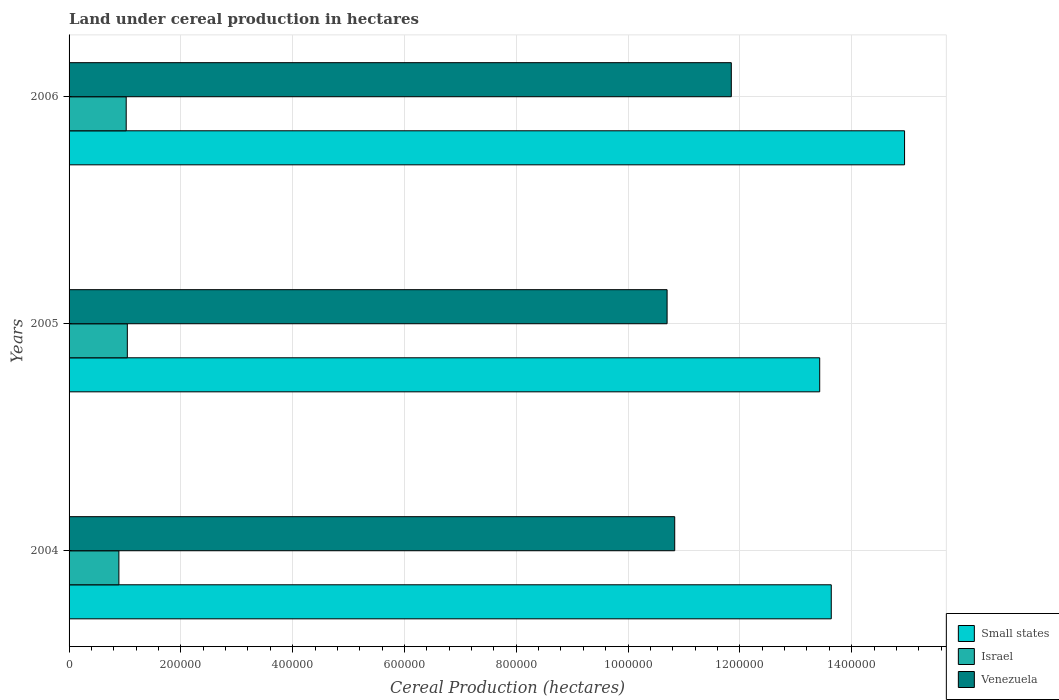How many different coloured bars are there?
Offer a terse response. 3. How many groups of bars are there?
Your response must be concise. 3. How many bars are there on the 3rd tick from the top?
Your answer should be compact. 3. How many bars are there on the 2nd tick from the bottom?
Your response must be concise. 3. What is the label of the 1st group of bars from the top?
Provide a succinct answer. 2006. What is the land under cereal production in Venezuela in 2005?
Ensure brevity in your answer.  1.07e+06. Across all years, what is the maximum land under cereal production in Small states?
Offer a terse response. 1.49e+06. Across all years, what is the minimum land under cereal production in Israel?
Ensure brevity in your answer.  8.91e+04. In which year was the land under cereal production in Israel minimum?
Your response must be concise. 2004. What is the total land under cereal production in Venezuela in the graph?
Keep it short and to the point. 3.34e+06. What is the difference between the land under cereal production in Small states in 2005 and that in 2006?
Keep it short and to the point. -1.52e+05. What is the difference between the land under cereal production in Venezuela in 2004 and the land under cereal production in Small states in 2005?
Provide a succinct answer. -2.59e+05. What is the average land under cereal production in Small states per year?
Give a very brief answer. 1.40e+06. In the year 2005, what is the difference between the land under cereal production in Small states and land under cereal production in Israel?
Offer a very short reply. 1.24e+06. In how many years, is the land under cereal production in Venezuela greater than 1280000 hectares?
Provide a short and direct response. 0. What is the ratio of the land under cereal production in Venezuela in 2004 to that in 2006?
Your response must be concise. 0.91. Is the land under cereal production in Israel in 2004 less than that in 2005?
Provide a short and direct response. Yes. What is the difference between the highest and the second highest land under cereal production in Small states?
Keep it short and to the point. 1.31e+05. What is the difference between the highest and the lowest land under cereal production in Small states?
Your answer should be very brief. 1.52e+05. What does the 3rd bar from the top in 2004 represents?
Keep it short and to the point. Small states. Is it the case that in every year, the sum of the land under cereal production in Israel and land under cereal production in Small states is greater than the land under cereal production in Venezuela?
Ensure brevity in your answer.  Yes. How many bars are there?
Offer a terse response. 9. Does the graph contain any zero values?
Your answer should be very brief. No. Does the graph contain grids?
Your answer should be very brief. Yes. How are the legend labels stacked?
Your answer should be compact. Vertical. What is the title of the graph?
Keep it short and to the point. Land under cereal production in hectares. What is the label or title of the X-axis?
Your answer should be compact. Cereal Production (hectares). What is the label or title of the Y-axis?
Offer a very short reply. Years. What is the Cereal Production (hectares) of Small states in 2004?
Offer a very short reply. 1.36e+06. What is the Cereal Production (hectares) in Israel in 2004?
Offer a very short reply. 8.91e+04. What is the Cereal Production (hectares) of Venezuela in 2004?
Your answer should be compact. 1.08e+06. What is the Cereal Production (hectares) of Small states in 2005?
Your answer should be very brief. 1.34e+06. What is the Cereal Production (hectares) of Israel in 2005?
Ensure brevity in your answer.  1.04e+05. What is the Cereal Production (hectares) in Venezuela in 2005?
Ensure brevity in your answer.  1.07e+06. What is the Cereal Production (hectares) of Small states in 2006?
Ensure brevity in your answer.  1.49e+06. What is the Cereal Production (hectares) in Israel in 2006?
Make the answer very short. 1.02e+05. What is the Cereal Production (hectares) in Venezuela in 2006?
Make the answer very short. 1.18e+06. Across all years, what is the maximum Cereal Production (hectares) in Small states?
Your response must be concise. 1.49e+06. Across all years, what is the maximum Cereal Production (hectares) in Israel?
Give a very brief answer. 1.04e+05. Across all years, what is the maximum Cereal Production (hectares) in Venezuela?
Your answer should be compact. 1.18e+06. Across all years, what is the minimum Cereal Production (hectares) of Small states?
Provide a short and direct response. 1.34e+06. Across all years, what is the minimum Cereal Production (hectares) in Israel?
Your response must be concise. 8.91e+04. Across all years, what is the minimum Cereal Production (hectares) of Venezuela?
Your answer should be very brief. 1.07e+06. What is the total Cereal Production (hectares) of Small states in the graph?
Ensure brevity in your answer.  4.20e+06. What is the total Cereal Production (hectares) of Israel in the graph?
Provide a short and direct response. 2.96e+05. What is the total Cereal Production (hectares) of Venezuela in the graph?
Ensure brevity in your answer.  3.34e+06. What is the difference between the Cereal Production (hectares) of Small states in 2004 and that in 2005?
Offer a very short reply. 2.07e+04. What is the difference between the Cereal Production (hectares) of Israel in 2004 and that in 2005?
Ensure brevity in your answer.  -1.51e+04. What is the difference between the Cereal Production (hectares) of Venezuela in 2004 and that in 2005?
Your answer should be compact. 1.36e+04. What is the difference between the Cereal Production (hectares) of Small states in 2004 and that in 2006?
Keep it short and to the point. -1.31e+05. What is the difference between the Cereal Production (hectares) of Israel in 2004 and that in 2006?
Give a very brief answer. -1.31e+04. What is the difference between the Cereal Production (hectares) in Venezuela in 2004 and that in 2006?
Give a very brief answer. -1.01e+05. What is the difference between the Cereal Production (hectares) in Small states in 2005 and that in 2006?
Your answer should be very brief. -1.52e+05. What is the difference between the Cereal Production (hectares) of Israel in 2005 and that in 2006?
Ensure brevity in your answer.  1998. What is the difference between the Cereal Production (hectares) of Venezuela in 2005 and that in 2006?
Offer a very short reply. -1.15e+05. What is the difference between the Cereal Production (hectares) in Small states in 2004 and the Cereal Production (hectares) in Israel in 2005?
Your answer should be very brief. 1.26e+06. What is the difference between the Cereal Production (hectares) in Small states in 2004 and the Cereal Production (hectares) in Venezuela in 2005?
Offer a very short reply. 2.94e+05. What is the difference between the Cereal Production (hectares) in Israel in 2004 and the Cereal Production (hectares) in Venezuela in 2005?
Provide a succinct answer. -9.81e+05. What is the difference between the Cereal Production (hectares) of Small states in 2004 and the Cereal Production (hectares) of Israel in 2006?
Your response must be concise. 1.26e+06. What is the difference between the Cereal Production (hectares) of Small states in 2004 and the Cereal Production (hectares) of Venezuela in 2006?
Offer a very short reply. 1.79e+05. What is the difference between the Cereal Production (hectares) of Israel in 2004 and the Cereal Production (hectares) of Venezuela in 2006?
Keep it short and to the point. -1.10e+06. What is the difference between the Cereal Production (hectares) of Small states in 2005 and the Cereal Production (hectares) of Israel in 2006?
Offer a very short reply. 1.24e+06. What is the difference between the Cereal Production (hectares) of Small states in 2005 and the Cereal Production (hectares) of Venezuela in 2006?
Offer a very short reply. 1.58e+05. What is the difference between the Cereal Production (hectares) of Israel in 2005 and the Cereal Production (hectares) of Venezuela in 2006?
Provide a succinct answer. -1.08e+06. What is the average Cereal Production (hectares) of Small states per year?
Your response must be concise. 1.40e+06. What is the average Cereal Production (hectares) of Israel per year?
Ensure brevity in your answer.  9.85e+04. What is the average Cereal Production (hectares) of Venezuela per year?
Offer a very short reply. 1.11e+06. In the year 2004, what is the difference between the Cereal Production (hectares) of Small states and Cereal Production (hectares) of Israel?
Make the answer very short. 1.27e+06. In the year 2004, what is the difference between the Cereal Production (hectares) of Small states and Cereal Production (hectares) of Venezuela?
Provide a succinct answer. 2.80e+05. In the year 2004, what is the difference between the Cereal Production (hectares) in Israel and Cereal Production (hectares) in Venezuela?
Make the answer very short. -9.94e+05. In the year 2005, what is the difference between the Cereal Production (hectares) in Small states and Cereal Production (hectares) in Israel?
Keep it short and to the point. 1.24e+06. In the year 2005, what is the difference between the Cereal Production (hectares) in Small states and Cereal Production (hectares) in Venezuela?
Make the answer very short. 2.73e+05. In the year 2005, what is the difference between the Cereal Production (hectares) in Israel and Cereal Production (hectares) in Venezuela?
Your answer should be very brief. -9.66e+05. In the year 2006, what is the difference between the Cereal Production (hectares) of Small states and Cereal Production (hectares) of Israel?
Give a very brief answer. 1.39e+06. In the year 2006, what is the difference between the Cereal Production (hectares) in Small states and Cereal Production (hectares) in Venezuela?
Your answer should be compact. 3.10e+05. In the year 2006, what is the difference between the Cereal Production (hectares) in Israel and Cereal Production (hectares) in Venezuela?
Your answer should be compact. -1.08e+06. What is the ratio of the Cereal Production (hectares) in Small states in 2004 to that in 2005?
Give a very brief answer. 1.02. What is the ratio of the Cereal Production (hectares) of Israel in 2004 to that in 2005?
Offer a terse response. 0.86. What is the ratio of the Cereal Production (hectares) of Venezuela in 2004 to that in 2005?
Make the answer very short. 1.01. What is the ratio of the Cereal Production (hectares) of Small states in 2004 to that in 2006?
Your response must be concise. 0.91. What is the ratio of the Cereal Production (hectares) of Israel in 2004 to that in 2006?
Offer a very short reply. 0.87. What is the ratio of the Cereal Production (hectares) in Venezuela in 2004 to that in 2006?
Offer a very short reply. 0.91. What is the ratio of the Cereal Production (hectares) in Small states in 2005 to that in 2006?
Your answer should be very brief. 0.9. What is the ratio of the Cereal Production (hectares) of Israel in 2005 to that in 2006?
Your response must be concise. 1.02. What is the ratio of the Cereal Production (hectares) of Venezuela in 2005 to that in 2006?
Keep it short and to the point. 0.9. What is the difference between the highest and the second highest Cereal Production (hectares) of Small states?
Ensure brevity in your answer.  1.31e+05. What is the difference between the highest and the second highest Cereal Production (hectares) in Israel?
Your answer should be compact. 1998. What is the difference between the highest and the second highest Cereal Production (hectares) of Venezuela?
Provide a short and direct response. 1.01e+05. What is the difference between the highest and the lowest Cereal Production (hectares) of Small states?
Offer a terse response. 1.52e+05. What is the difference between the highest and the lowest Cereal Production (hectares) of Israel?
Keep it short and to the point. 1.51e+04. What is the difference between the highest and the lowest Cereal Production (hectares) in Venezuela?
Your answer should be compact. 1.15e+05. 